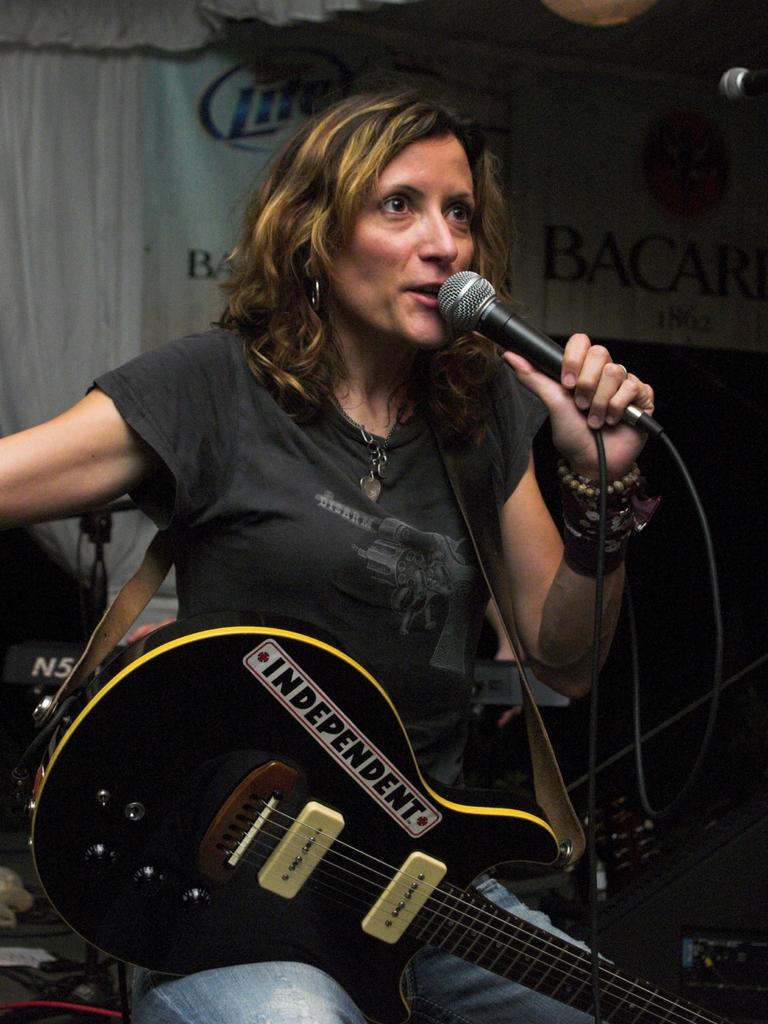Please provide a concise description of this image. As we can see in the image there is a woman holding mic and a guitar. 